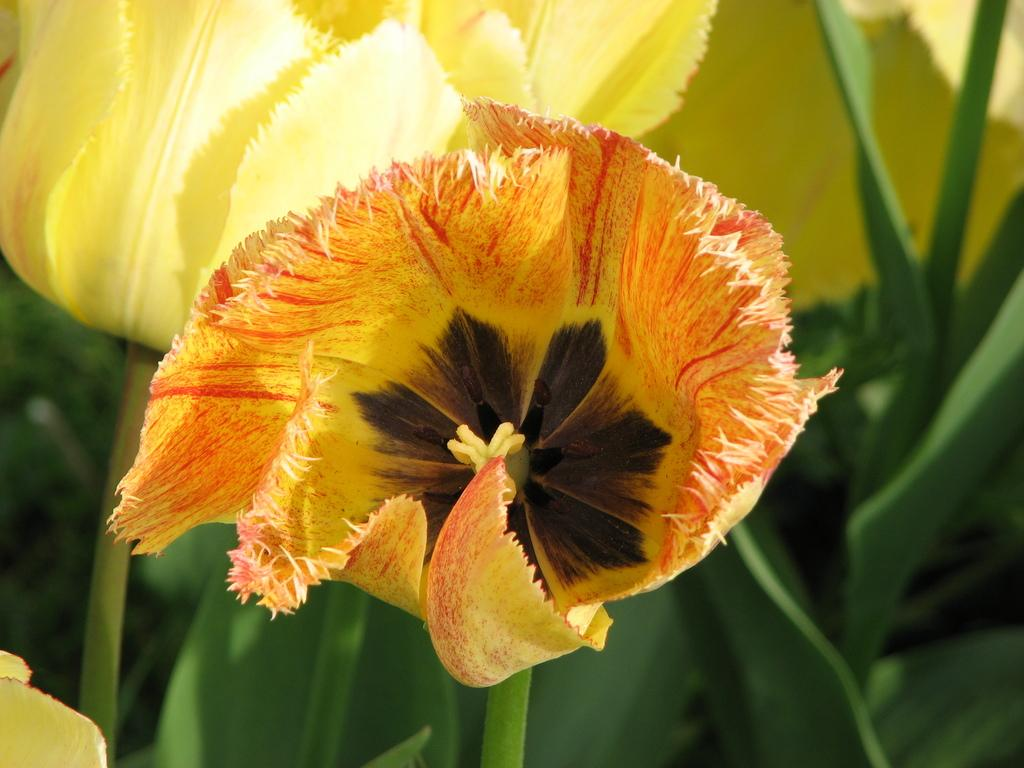What type of plant life can be seen in the image? There are flowers and leaves in the image. Can you describe the flowers in the image? The facts provided do not give specific details about the flowers, so we cannot describe them further. What is the relationship between the flowers and leaves in the image? The flowers and leaves are likely part of the same plant or plants in the image. What type of baby is visible in the image? There is no baby present in the image; it only features flowers and leaves. What is the purpose of the operation being performed on the flowers in the image? There is no operation being performed on the flowers in the image; they are simply depicted as part of the plant life. 